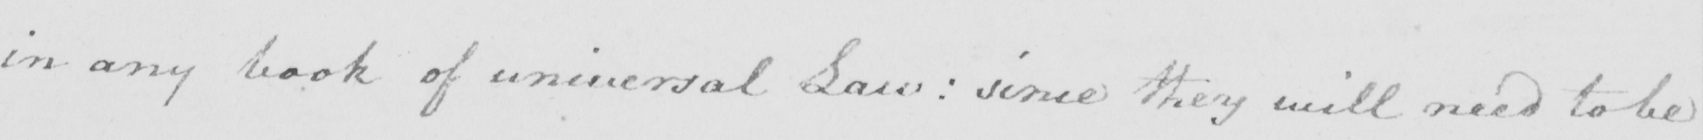Transcribe the text shown in this historical manuscript line. in any book of universal Law :  since they will need to be 